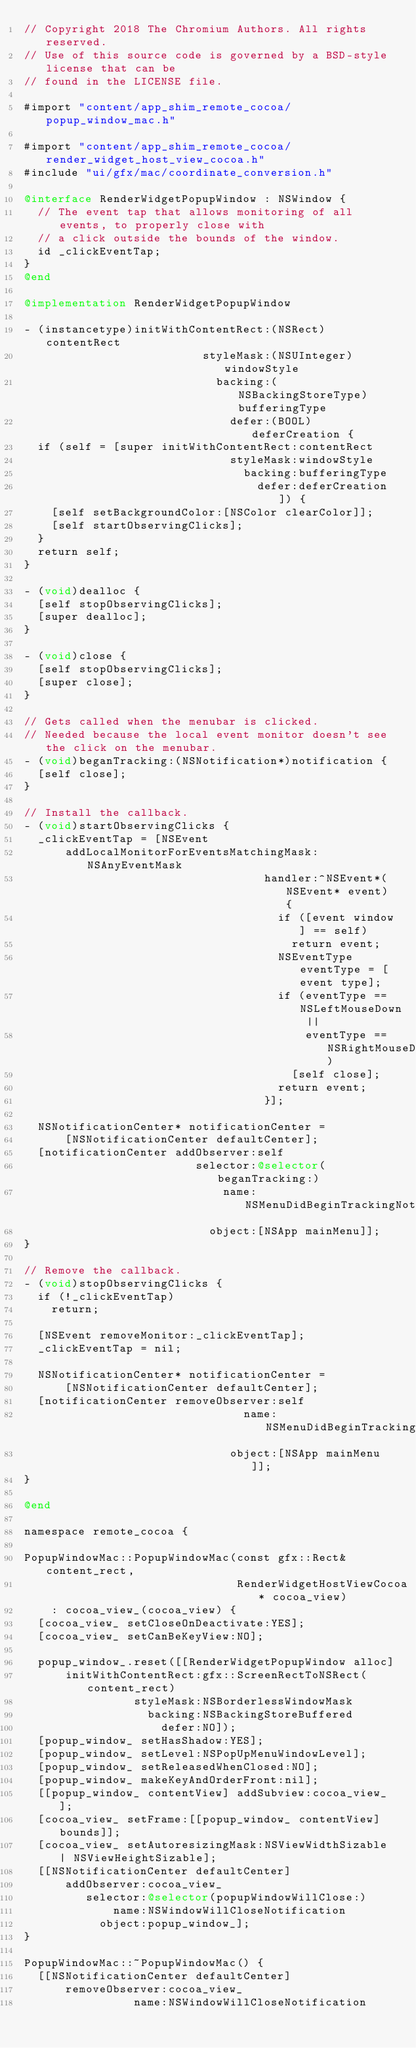Convert code to text. <code><loc_0><loc_0><loc_500><loc_500><_ObjectiveC_>// Copyright 2018 The Chromium Authors. All rights reserved.
// Use of this source code is governed by a BSD-style license that can be
// found in the LICENSE file.

#import "content/app_shim_remote_cocoa/popup_window_mac.h"

#import "content/app_shim_remote_cocoa/render_widget_host_view_cocoa.h"
#include "ui/gfx/mac/coordinate_conversion.h"

@interface RenderWidgetPopupWindow : NSWindow {
  // The event tap that allows monitoring of all events, to properly close with
  // a click outside the bounds of the window.
  id _clickEventTap;
}
@end

@implementation RenderWidgetPopupWindow

- (instancetype)initWithContentRect:(NSRect)contentRect
                          styleMask:(NSUInteger)windowStyle
                            backing:(NSBackingStoreType)bufferingType
                              defer:(BOOL)deferCreation {
  if (self = [super initWithContentRect:contentRect
                              styleMask:windowStyle
                                backing:bufferingType
                                  defer:deferCreation]) {
    [self setBackgroundColor:[NSColor clearColor]];
    [self startObservingClicks];
  }
  return self;
}

- (void)dealloc {
  [self stopObservingClicks];
  [super dealloc];
}

- (void)close {
  [self stopObservingClicks];
  [super close];
}

// Gets called when the menubar is clicked.
// Needed because the local event monitor doesn't see the click on the menubar.
- (void)beganTracking:(NSNotification*)notification {
  [self close];
}

// Install the callback.
- (void)startObservingClicks {
  _clickEventTap = [NSEvent
      addLocalMonitorForEventsMatchingMask:NSAnyEventMask
                                   handler:^NSEvent*(NSEvent* event) {
                                     if ([event window] == self)
                                       return event;
                                     NSEventType eventType = [event type];
                                     if (eventType == NSLeftMouseDown ||
                                         eventType == NSRightMouseDown)
                                       [self close];
                                     return event;
                                   }];

  NSNotificationCenter* notificationCenter =
      [NSNotificationCenter defaultCenter];
  [notificationCenter addObserver:self
                         selector:@selector(beganTracking:)
                             name:NSMenuDidBeginTrackingNotification
                           object:[NSApp mainMenu]];
}

// Remove the callback.
- (void)stopObservingClicks {
  if (!_clickEventTap)
    return;

  [NSEvent removeMonitor:_clickEventTap];
  _clickEventTap = nil;

  NSNotificationCenter* notificationCenter =
      [NSNotificationCenter defaultCenter];
  [notificationCenter removeObserver:self
                                name:NSMenuDidBeginTrackingNotification
                              object:[NSApp mainMenu]];
}

@end

namespace remote_cocoa {

PopupWindowMac::PopupWindowMac(const gfx::Rect& content_rect,
                               RenderWidgetHostViewCocoa* cocoa_view)
    : cocoa_view_(cocoa_view) {
  [cocoa_view_ setCloseOnDeactivate:YES];
  [cocoa_view_ setCanBeKeyView:NO];

  popup_window_.reset([[RenderWidgetPopupWindow alloc]
      initWithContentRect:gfx::ScreenRectToNSRect(content_rect)
                styleMask:NSBorderlessWindowMask
                  backing:NSBackingStoreBuffered
                    defer:NO]);
  [popup_window_ setHasShadow:YES];
  [popup_window_ setLevel:NSPopUpMenuWindowLevel];
  [popup_window_ setReleasedWhenClosed:NO];
  [popup_window_ makeKeyAndOrderFront:nil];
  [[popup_window_ contentView] addSubview:cocoa_view_];
  [cocoa_view_ setFrame:[[popup_window_ contentView] bounds]];
  [cocoa_view_ setAutoresizingMask:NSViewWidthSizable | NSViewHeightSizable];
  [[NSNotificationCenter defaultCenter]
      addObserver:cocoa_view_
         selector:@selector(popupWindowWillClose:)
             name:NSWindowWillCloseNotification
           object:popup_window_];
}

PopupWindowMac::~PopupWindowMac() {
  [[NSNotificationCenter defaultCenter]
      removeObserver:cocoa_view_
                name:NSWindowWillCloseNotification</code> 